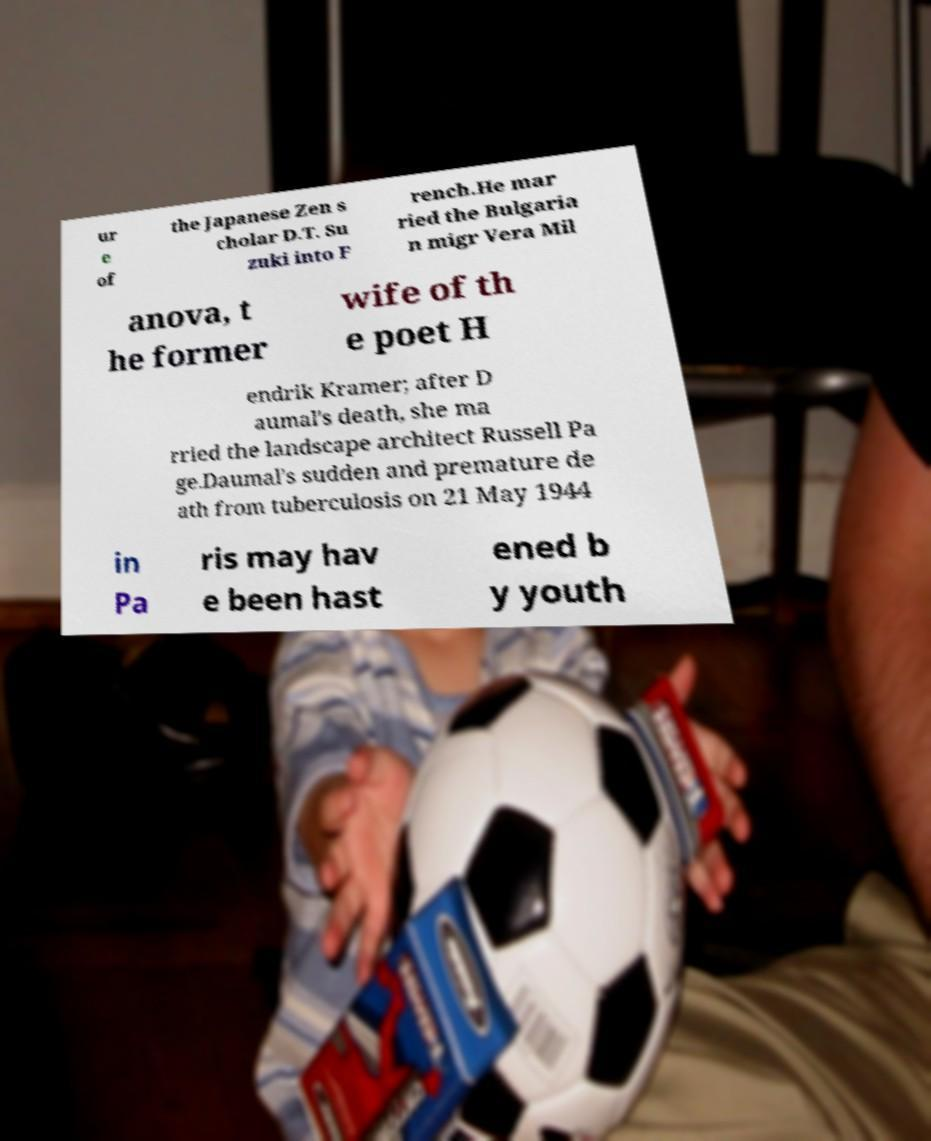There's text embedded in this image that I need extracted. Can you transcribe it verbatim? ur e of the Japanese Zen s cholar D.T. Su zuki into F rench.He mar ried the Bulgaria n migr Vera Mil anova, t he former wife of th e poet H endrik Kramer; after D aumal's death, she ma rried the landscape architect Russell Pa ge.Daumal's sudden and premature de ath from tuberculosis on 21 May 1944 in Pa ris may hav e been hast ened b y youth 